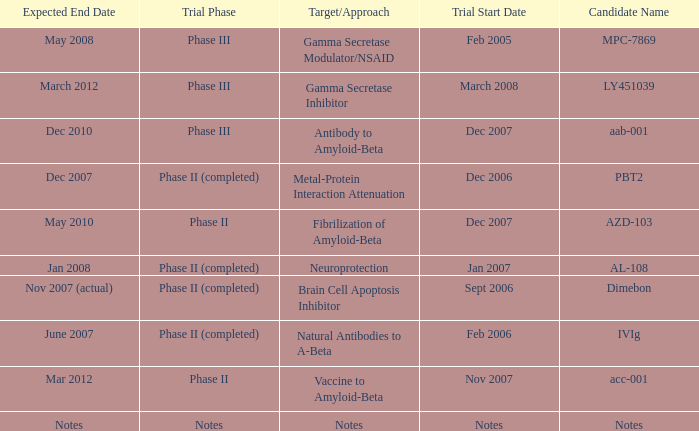What is Trial Start Date, when Candidate Name is PBT2? Dec 2006. 